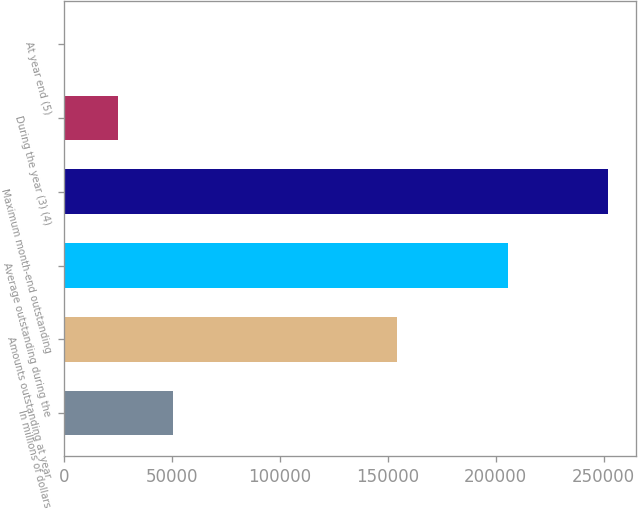Convert chart to OTSL. <chart><loc_0><loc_0><loc_500><loc_500><bar_chart><fcel>In millions of dollars<fcel>Amounts outstanding at year<fcel>Average outstanding during the<fcel>Maximum month-end outstanding<fcel>During the year (3) (4)<fcel>At year end (5)<nl><fcel>50431.5<fcel>154281<fcel>205633<fcel>252154<fcel>25216.2<fcel>0.85<nl></chart> 